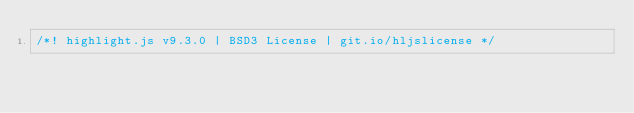<code> <loc_0><loc_0><loc_500><loc_500><_JavaScript_>/*! highlight.js v9.3.0 | BSD3 License | git.io/hljslicense */</code> 